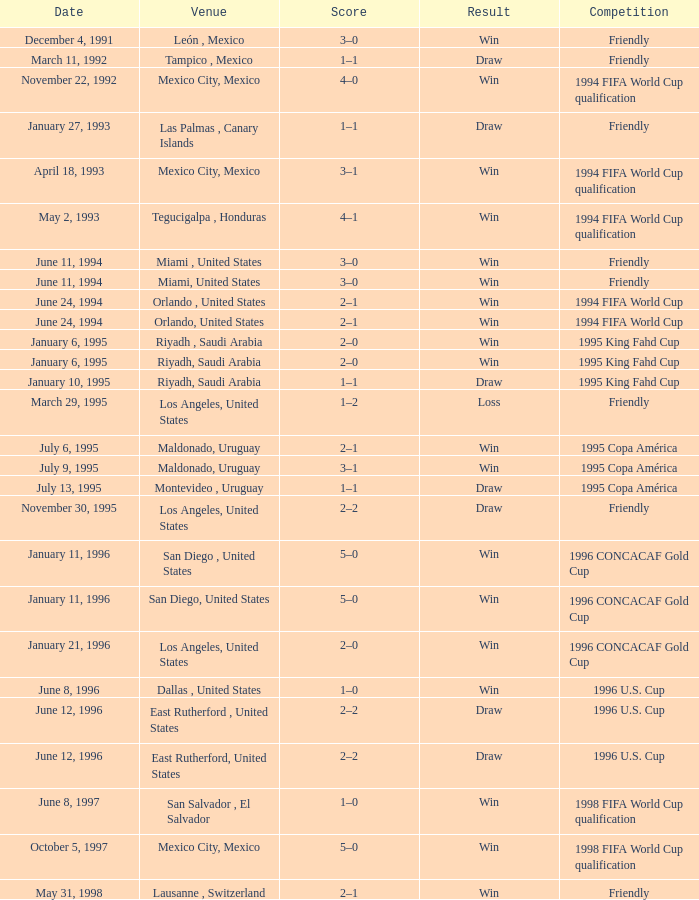What is Venue, when Date is "January 6, 1995"? Riyadh , Saudi Arabia, Riyadh, Saudi Arabia. 